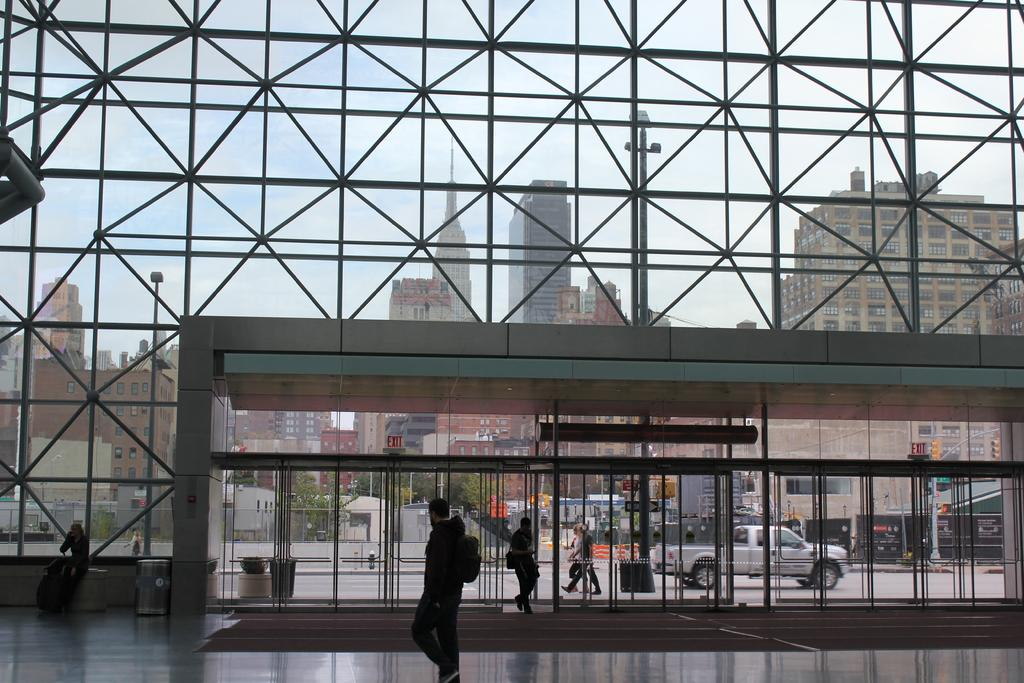What type of structures can be seen in the image? There are buildings in the image. What other natural elements are present in the image? There are trees in the image. Can you describe the people in the image? There is a group of people in the image. What traffic control devices are visible in the image? There are traffic lights on the right side of the image. What mode of transportation can be seen in the image? There is a car on the right side of the image. What type of industry is depicted in the image? There is no specific industry depicted in the image; it features buildings, trees, a group of people, traffic lights, and a car. How many laborers are visible in the image? There is no mention of laborers in the image; it only shows a group of people, traffic lights, a car, and a general urban setting. 